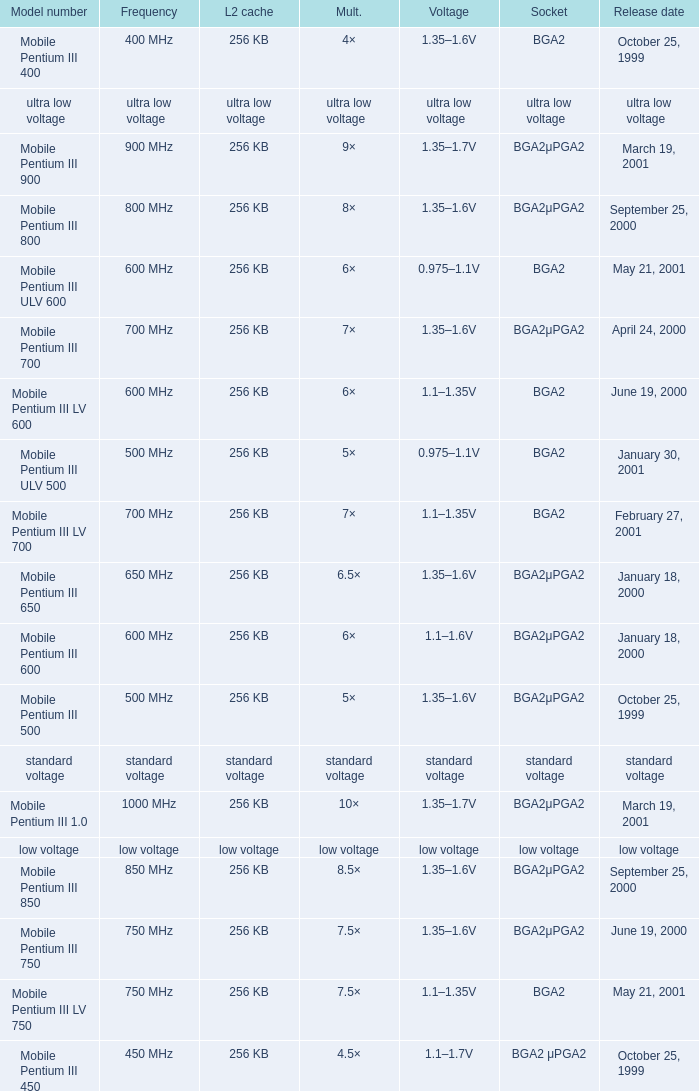Which model has a frequency of 750 mhz and a socket of bga2μpga2? Mobile Pentium III 750. 